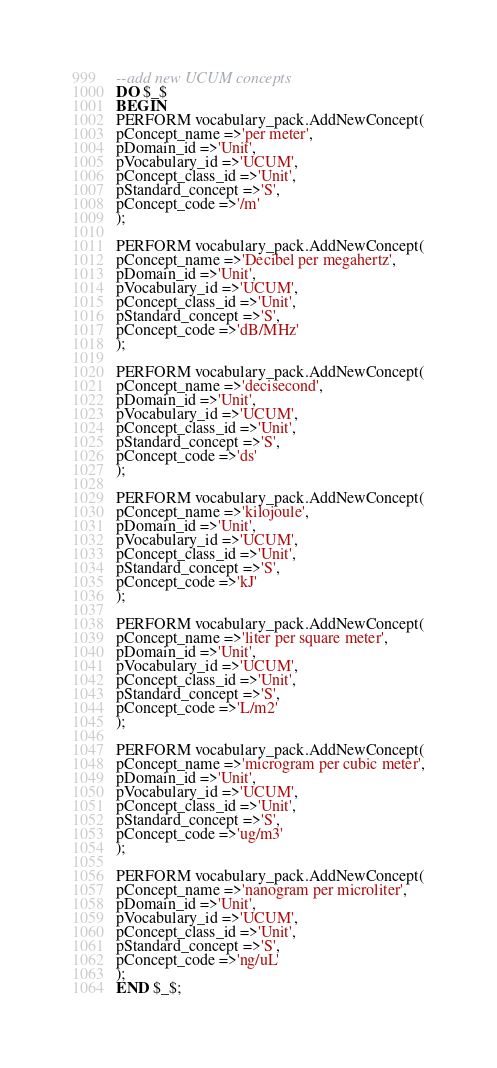Convert code to text. <code><loc_0><loc_0><loc_500><loc_500><_SQL_>--add new UCUM concepts
DO $_$
BEGIN
PERFORM vocabulary_pack.AddNewConcept(
pConcept_name =>'per meter',
pDomain_id =>'Unit',
pVocabulary_id =>'UCUM',
pConcept_class_id =>'Unit',
pStandard_concept =>'S',
pConcept_code =>'/m'
);

PERFORM vocabulary_pack.AddNewConcept(
pConcept_name =>'Decibel per megahertz',
pDomain_id =>'Unit',
pVocabulary_id =>'UCUM',
pConcept_class_id =>'Unit',
pStandard_concept =>'S',
pConcept_code =>'dB/MHz'
);

PERFORM vocabulary_pack.AddNewConcept(
pConcept_name =>'decisecond',
pDomain_id =>'Unit',
pVocabulary_id =>'UCUM',
pConcept_class_id =>'Unit',
pStandard_concept =>'S',
pConcept_code =>'ds'
);

PERFORM vocabulary_pack.AddNewConcept(
pConcept_name =>'kilojoule',
pDomain_id =>'Unit',
pVocabulary_id =>'UCUM',
pConcept_class_id =>'Unit',
pStandard_concept =>'S',
pConcept_code =>'kJ'
);

PERFORM vocabulary_pack.AddNewConcept(
pConcept_name =>'liter per square meter',
pDomain_id =>'Unit',
pVocabulary_id =>'UCUM',
pConcept_class_id =>'Unit',
pStandard_concept =>'S',
pConcept_code =>'L/m2'
);

PERFORM vocabulary_pack.AddNewConcept(
pConcept_name =>'microgram per cubic meter',
pDomain_id =>'Unit',
pVocabulary_id =>'UCUM',
pConcept_class_id =>'Unit',
pStandard_concept =>'S',
pConcept_code =>'ug/m3'
);

PERFORM vocabulary_pack.AddNewConcept(
pConcept_name =>'nanogram per microliter',
pDomain_id =>'Unit',
pVocabulary_id =>'UCUM',
pConcept_class_id =>'Unit',
pStandard_concept =>'S',
pConcept_code =>'ng/uL'
);
END $_$;
</code> 